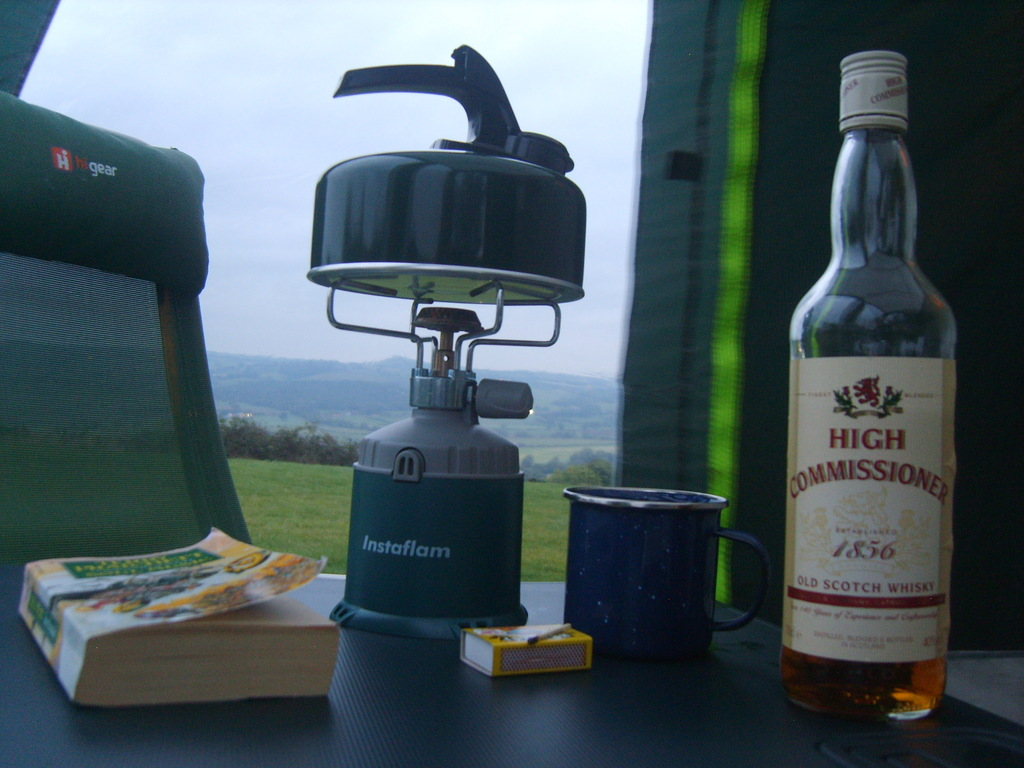How might the weather affect a camping experience like the one shown? The overcast sky suggests cooler temperatures which might require warm clothing and bedding. Such weather also heightens the enjoyment of warm drinks and may influence activities like hiking, possibly making trails muddier or affecting visibility. 